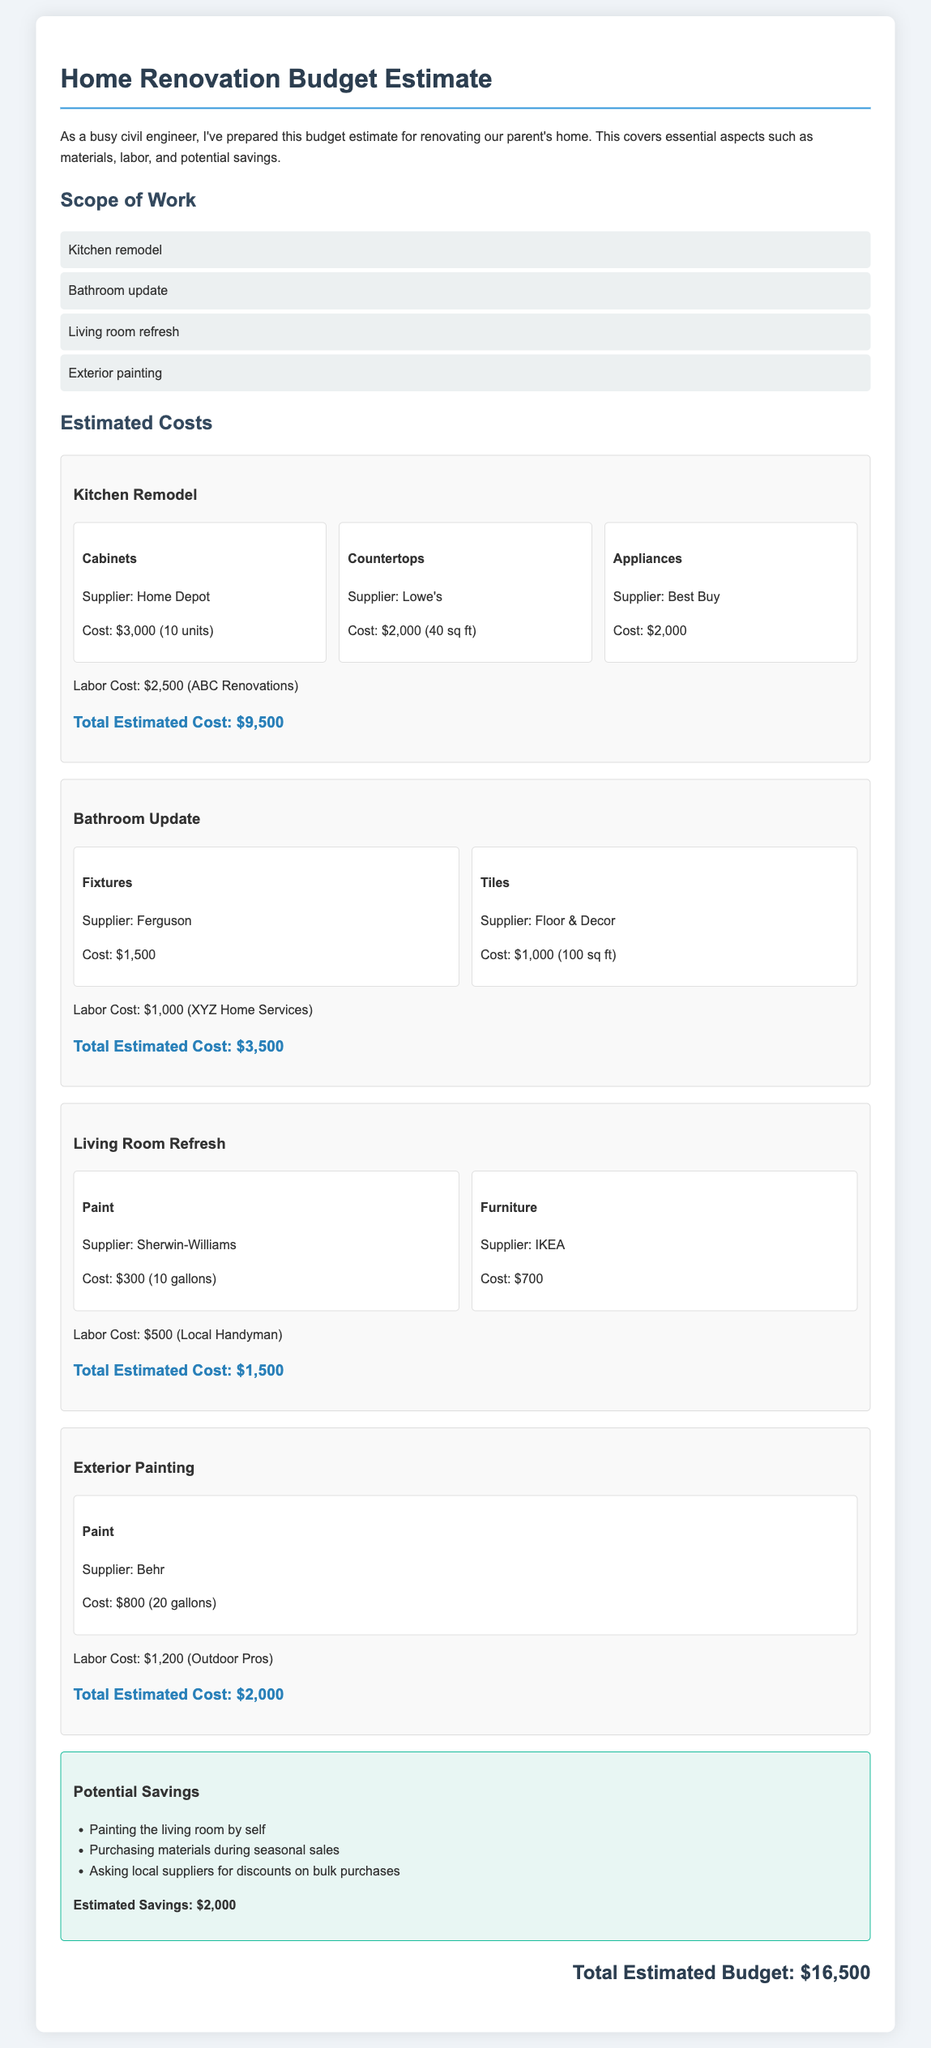What is the total estimated budget? The total estimated budget is explicitly stated at the end of the document.
Answer: $16,500 Who is the supplier for the kitchen cabinets? The document lists the supplier of the kitchen cabinets in the estimated costs section.
Answer: Home Depot What is the labor cost for the bathroom update? The labor cost for the bathroom update is provided in the estimate section for that work.
Answer: $1,000 Which item has the highest estimated cost? The total estimated costs for each section indicate which is the highest, which is in the kitchen remodel section.
Answer: $9,500 What are one of the potential savings listed? The document outlines potential savings strategies in a dedicated section.
Answer: Painting the living room by self How many gallons of paint are needed for the living room? The specific amount of paint needed for the living room is mentioned in the estimated costs.
Answer: 10 gallons Who is the labor provider for exterior painting? The labor provider for the exterior painting task is specified in the cost section of that work.
Answer: Outdoor Pros What is the total estimated cost for the living room refresh? The total estimated cost for the living room refresh is clearly indicated in the cost section.
Answer: $1,500 How many square feet are covered by the tiles in the bathroom update? The document mentions the coverage area of the tiles in the bathroom update section.
Answer: 100 sq ft 